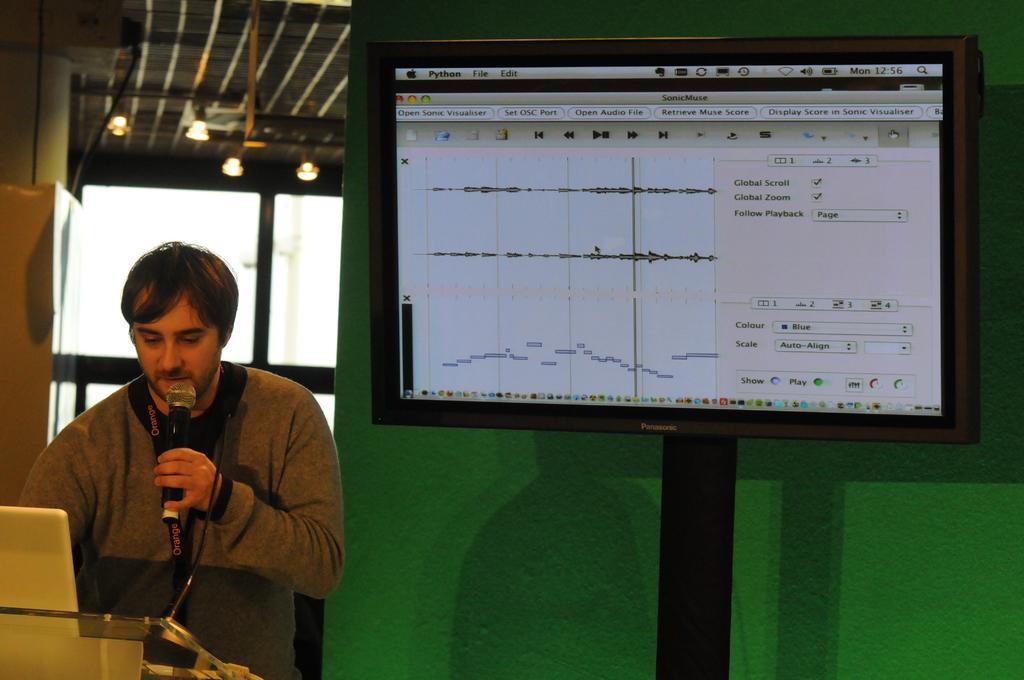Please provide a concise description of this image. In this picture I can see on the left side a man is speaking in the microphone. On the right side there is a t. v. in that there are graphs, there are lights at the top. 